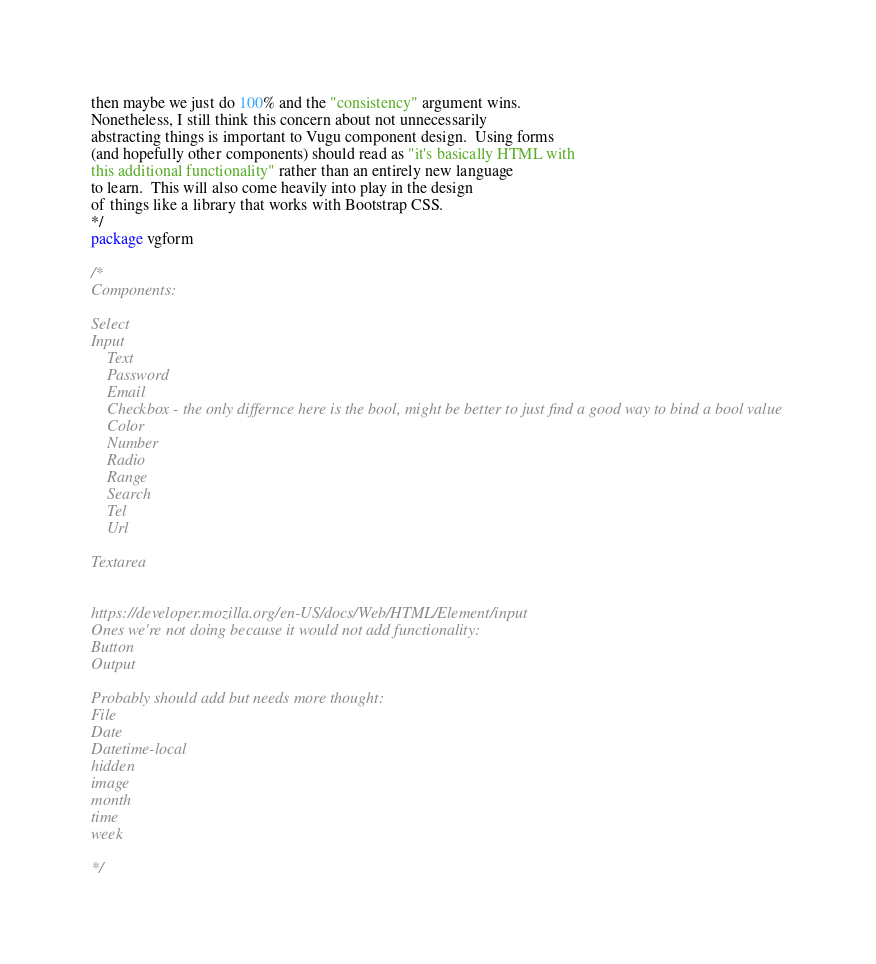Convert code to text. <code><loc_0><loc_0><loc_500><loc_500><_Go_>then maybe we just do 100% and the "consistency" argument wins.
Nonetheless, I still think this concern about not unnecessarily
abstracting things is important to Vugu component design.  Using forms
(and hopefully other components) should read as "it's basically HTML with
this additional functionality" rather than an entirely new language
to learn.  This will also come heavily into play in the design
of things like a library that works with Bootstrap CSS.
*/
package vgform

/*
Components:

Select
Input
	Text
	Password
	Email
    Checkbox - the only differnce here is the bool, might be better to just find a good way to bind a bool value
	Color
	Number
	Radio
	Range
	Search
	Tel
	Url

Textarea


https://developer.mozilla.org/en-US/docs/Web/HTML/Element/input
Ones we're not doing because it would not add functionality:
Button
Output

Probably should add but needs more thought:
File
Date
Datetime-local
hidden
image
month
time
week

*/
</code> 